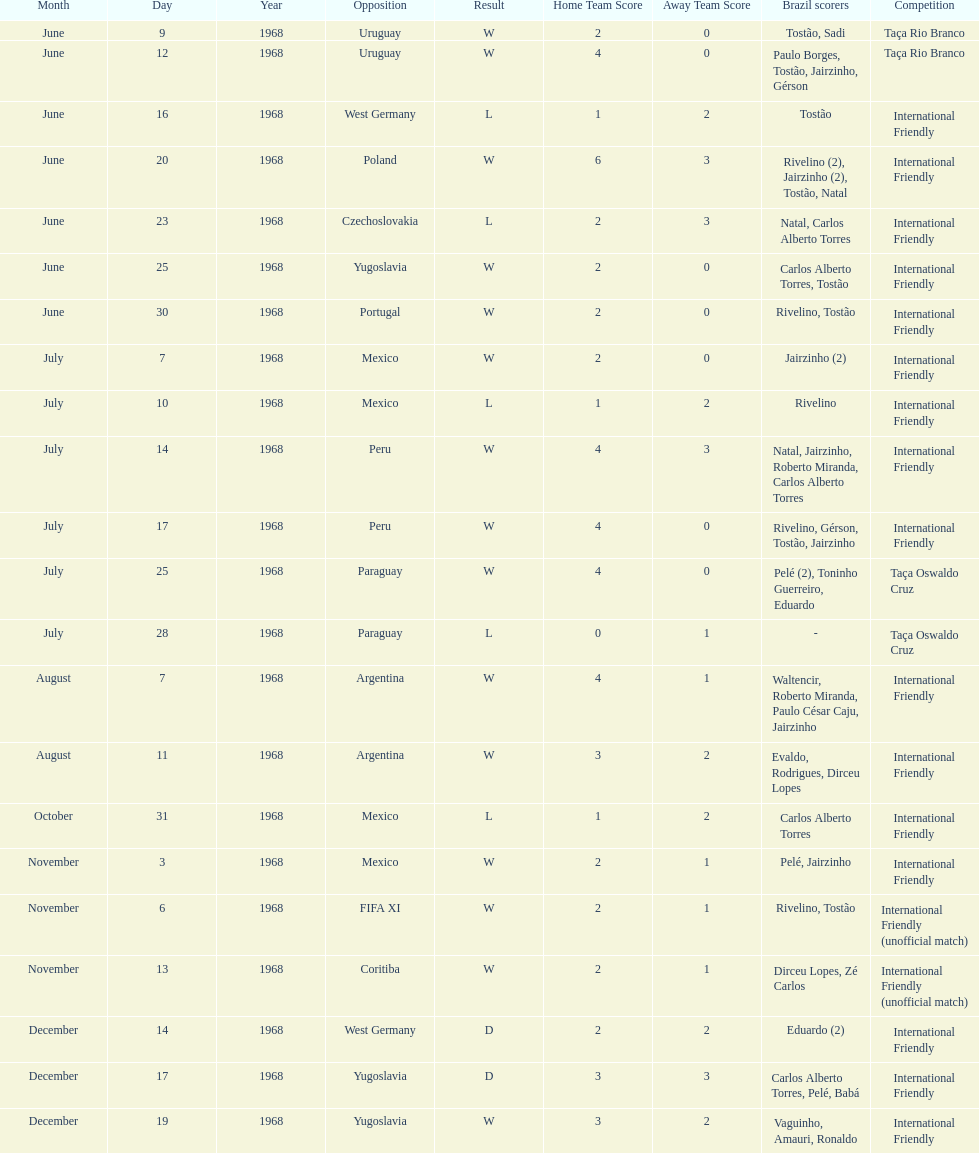How many times did brazil play against argentina in the international friendly competition? 2. 